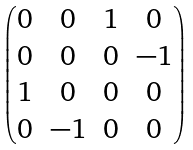<formula> <loc_0><loc_0><loc_500><loc_500>\begin{pmatrix} 0 & 0 & 1 & 0 \\ 0 & 0 & 0 & - 1 \\ 1 & 0 & 0 & 0 \\ 0 & - 1 & 0 & 0 \end{pmatrix}</formula> 